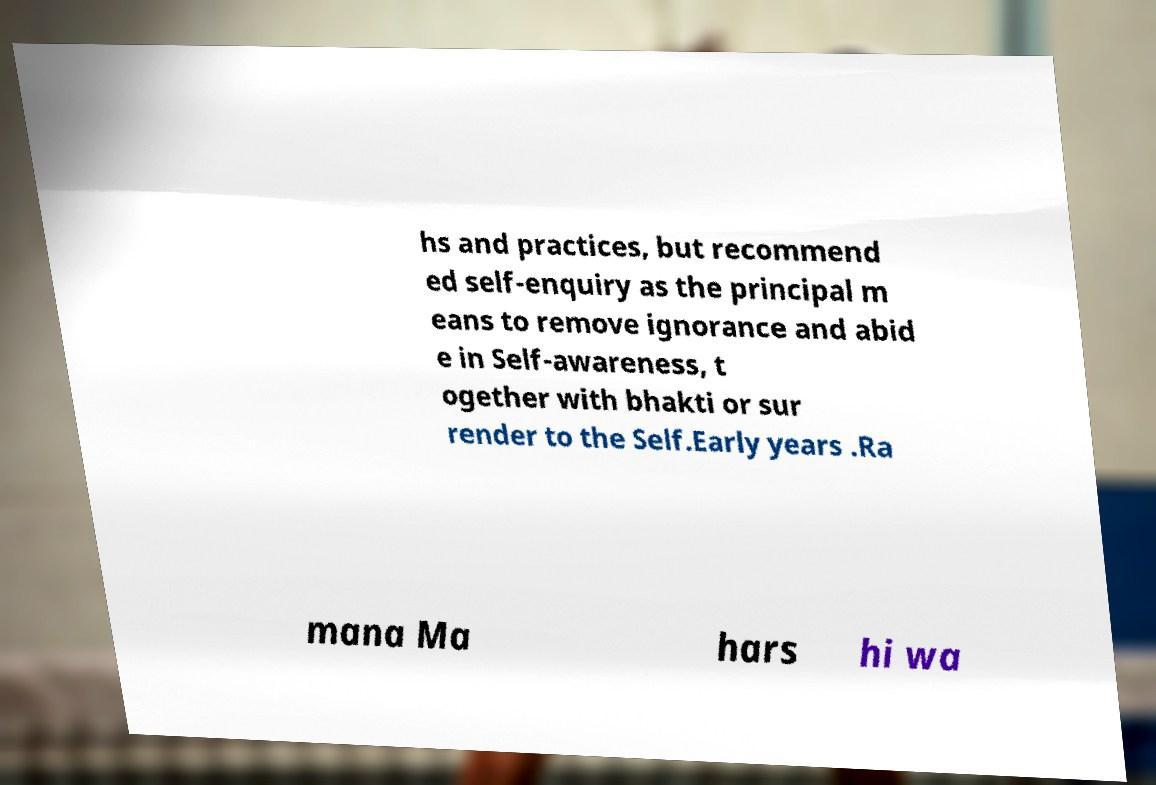Could you extract and type out the text from this image? hs and practices, but recommend ed self-enquiry as the principal m eans to remove ignorance and abid e in Self-awareness, t ogether with bhakti or sur render to the Self.Early years .Ra mana Ma hars hi wa 